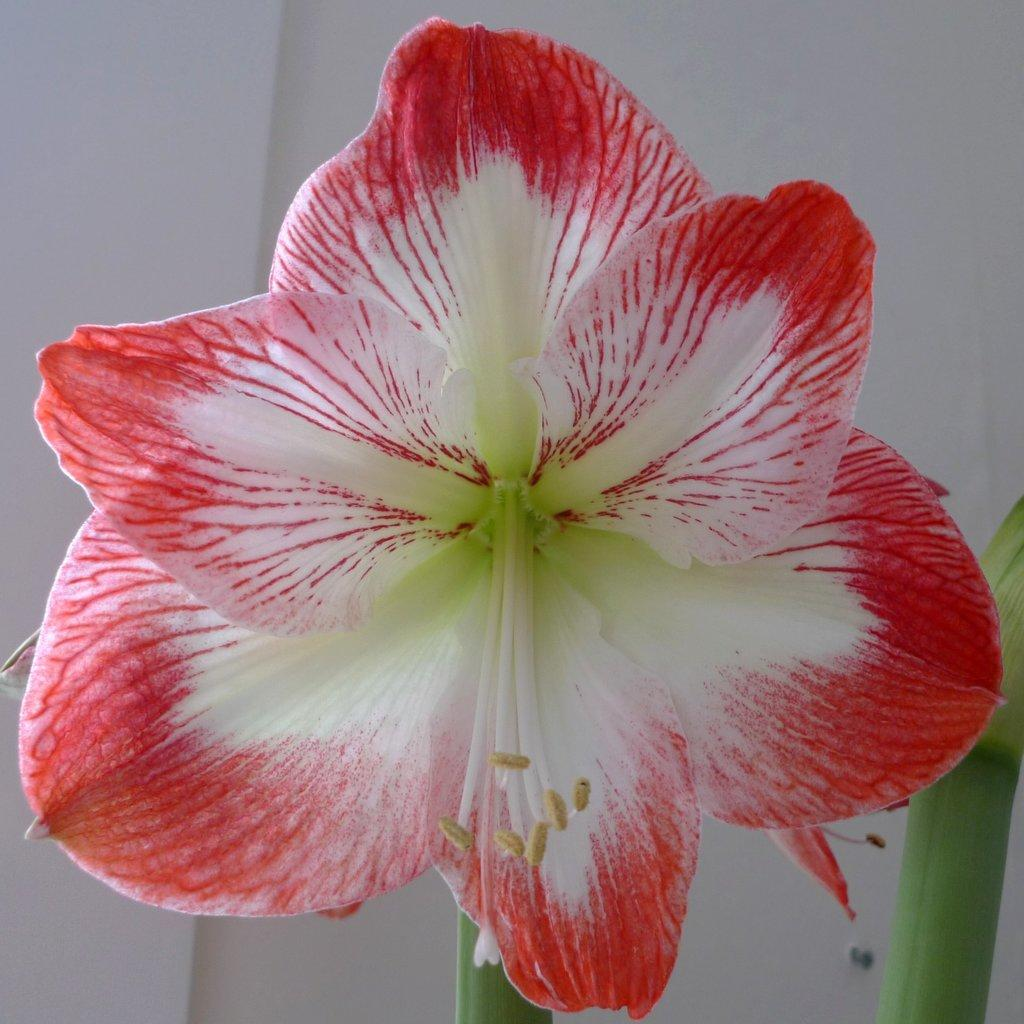What is present in the image? There is a wall in the image. Can you describe the surroundings of the wall? There is another wall visible on the backside. What type of bubble can be seen floating near the wall in the image? There is no bubble present in the image; it only features two walls. 